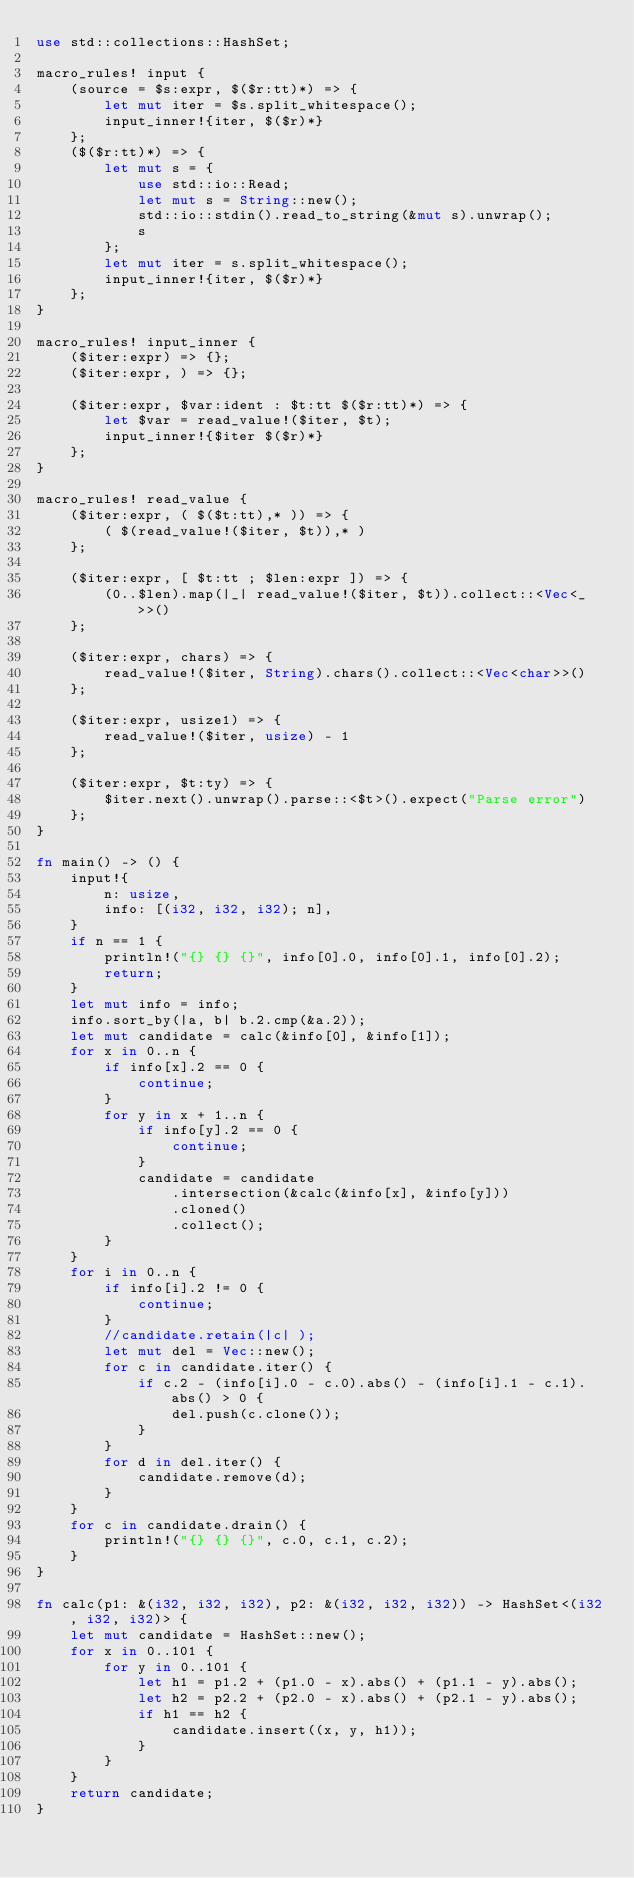Convert code to text. <code><loc_0><loc_0><loc_500><loc_500><_Rust_>use std::collections::HashSet;

macro_rules! input {
    (source = $s:expr, $($r:tt)*) => {
        let mut iter = $s.split_whitespace();
        input_inner!{iter, $($r)*}
    };
    ($($r:tt)*) => {
        let mut s = {
            use std::io::Read;
            let mut s = String::new();
            std::io::stdin().read_to_string(&mut s).unwrap();
            s
        };
        let mut iter = s.split_whitespace();
        input_inner!{iter, $($r)*}
    };
}

macro_rules! input_inner {
    ($iter:expr) => {};
    ($iter:expr, ) => {};

    ($iter:expr, $var:ident : $t:tt $($r:tt)*) => {
        let $var = read_value!($iter, $t);
        input_inner!{$iter $($r)*}
    };
}

macro_rules! read_value {
    ($iter:expr, ( $($t:tt),* )) => {
        ( $(read_value!($iter, $t)),* )
    };

    ($iter:expr, [ $t:tt ; $len:expr ]) => {
        (0..$len).map(|_| read_value!($iter, $t)).collect::<Vec<_>>()
    };

    ($iter:expr, chars) => {
        read_value!($iter, String).chars().collect::<Vec<char>>()
    };

    ($iter:expr, usize1) => {
        read_value!($iter, usize) - 1
    };

    ($iter:expr, $t:ty) => {
        $iter.next().unwrap().parse::<$t>().expect("Parse error")
    };
}

fn main() -> () {
    input!{
        n: usize,
        info: [(i32, i32, i32); n],
    }
    if n == 1 {
        println!("{} {} {}", info[0].0, info[0].1, info[0].2);
        return;
    }
    let mut info = info;
    info.sort_by(|a, b| b.2.cmp(&a.2));
    let mut candidate = calc(&info[0], &info[1]);
    for x in 0..n {
        if info[x].2 == 0 {
            continue;
        }
        for y in x + 1..n {
            if info[y].2 == 0 {
                continue;
            }
            candidate = candidate
                .intersection(&calc(&info[x], &info[y]))
                .cloned()
                .collect();
        }
    }
    for i in 0..n {
        if info[i].2 != 0 {
            continue;
        }
        //candidate.retain(|c| );
        let mut del = Vec::new();
        for c in candidate.iter() {
            if c.2 - (info[i].0 - c.0).abs() - (info[i].1 - c.1).abs() > 0 {
                del.push(c.clone());
            }
        }
        for d in del.iter() {
            candidate.remove(d);
        }
    }
    for c in candidate.drain() {
        println!("{} {} {}", c.0, c.1, c.2);
    }
}

fn calc(p1: &(i32, i32, i32), p2: &(i32, i32, i32)) -> HashSet<(i32, i32, i32)> {
    let mut candidate = HashSet::new();
    for x in 0..101 {
        for y in 0..101 {
            let h1 = p1.2 + (p1.0 - x).abs() + (p1.1 - y).abs();
            let h2 = p2.2 + (p2.0 - x).abs() + (p2.1 - y).abs();
            if h1 == h2 {
                candidate.insert((x, y, h1));
            }
        }
    }
    return candidate;
}
</code> 